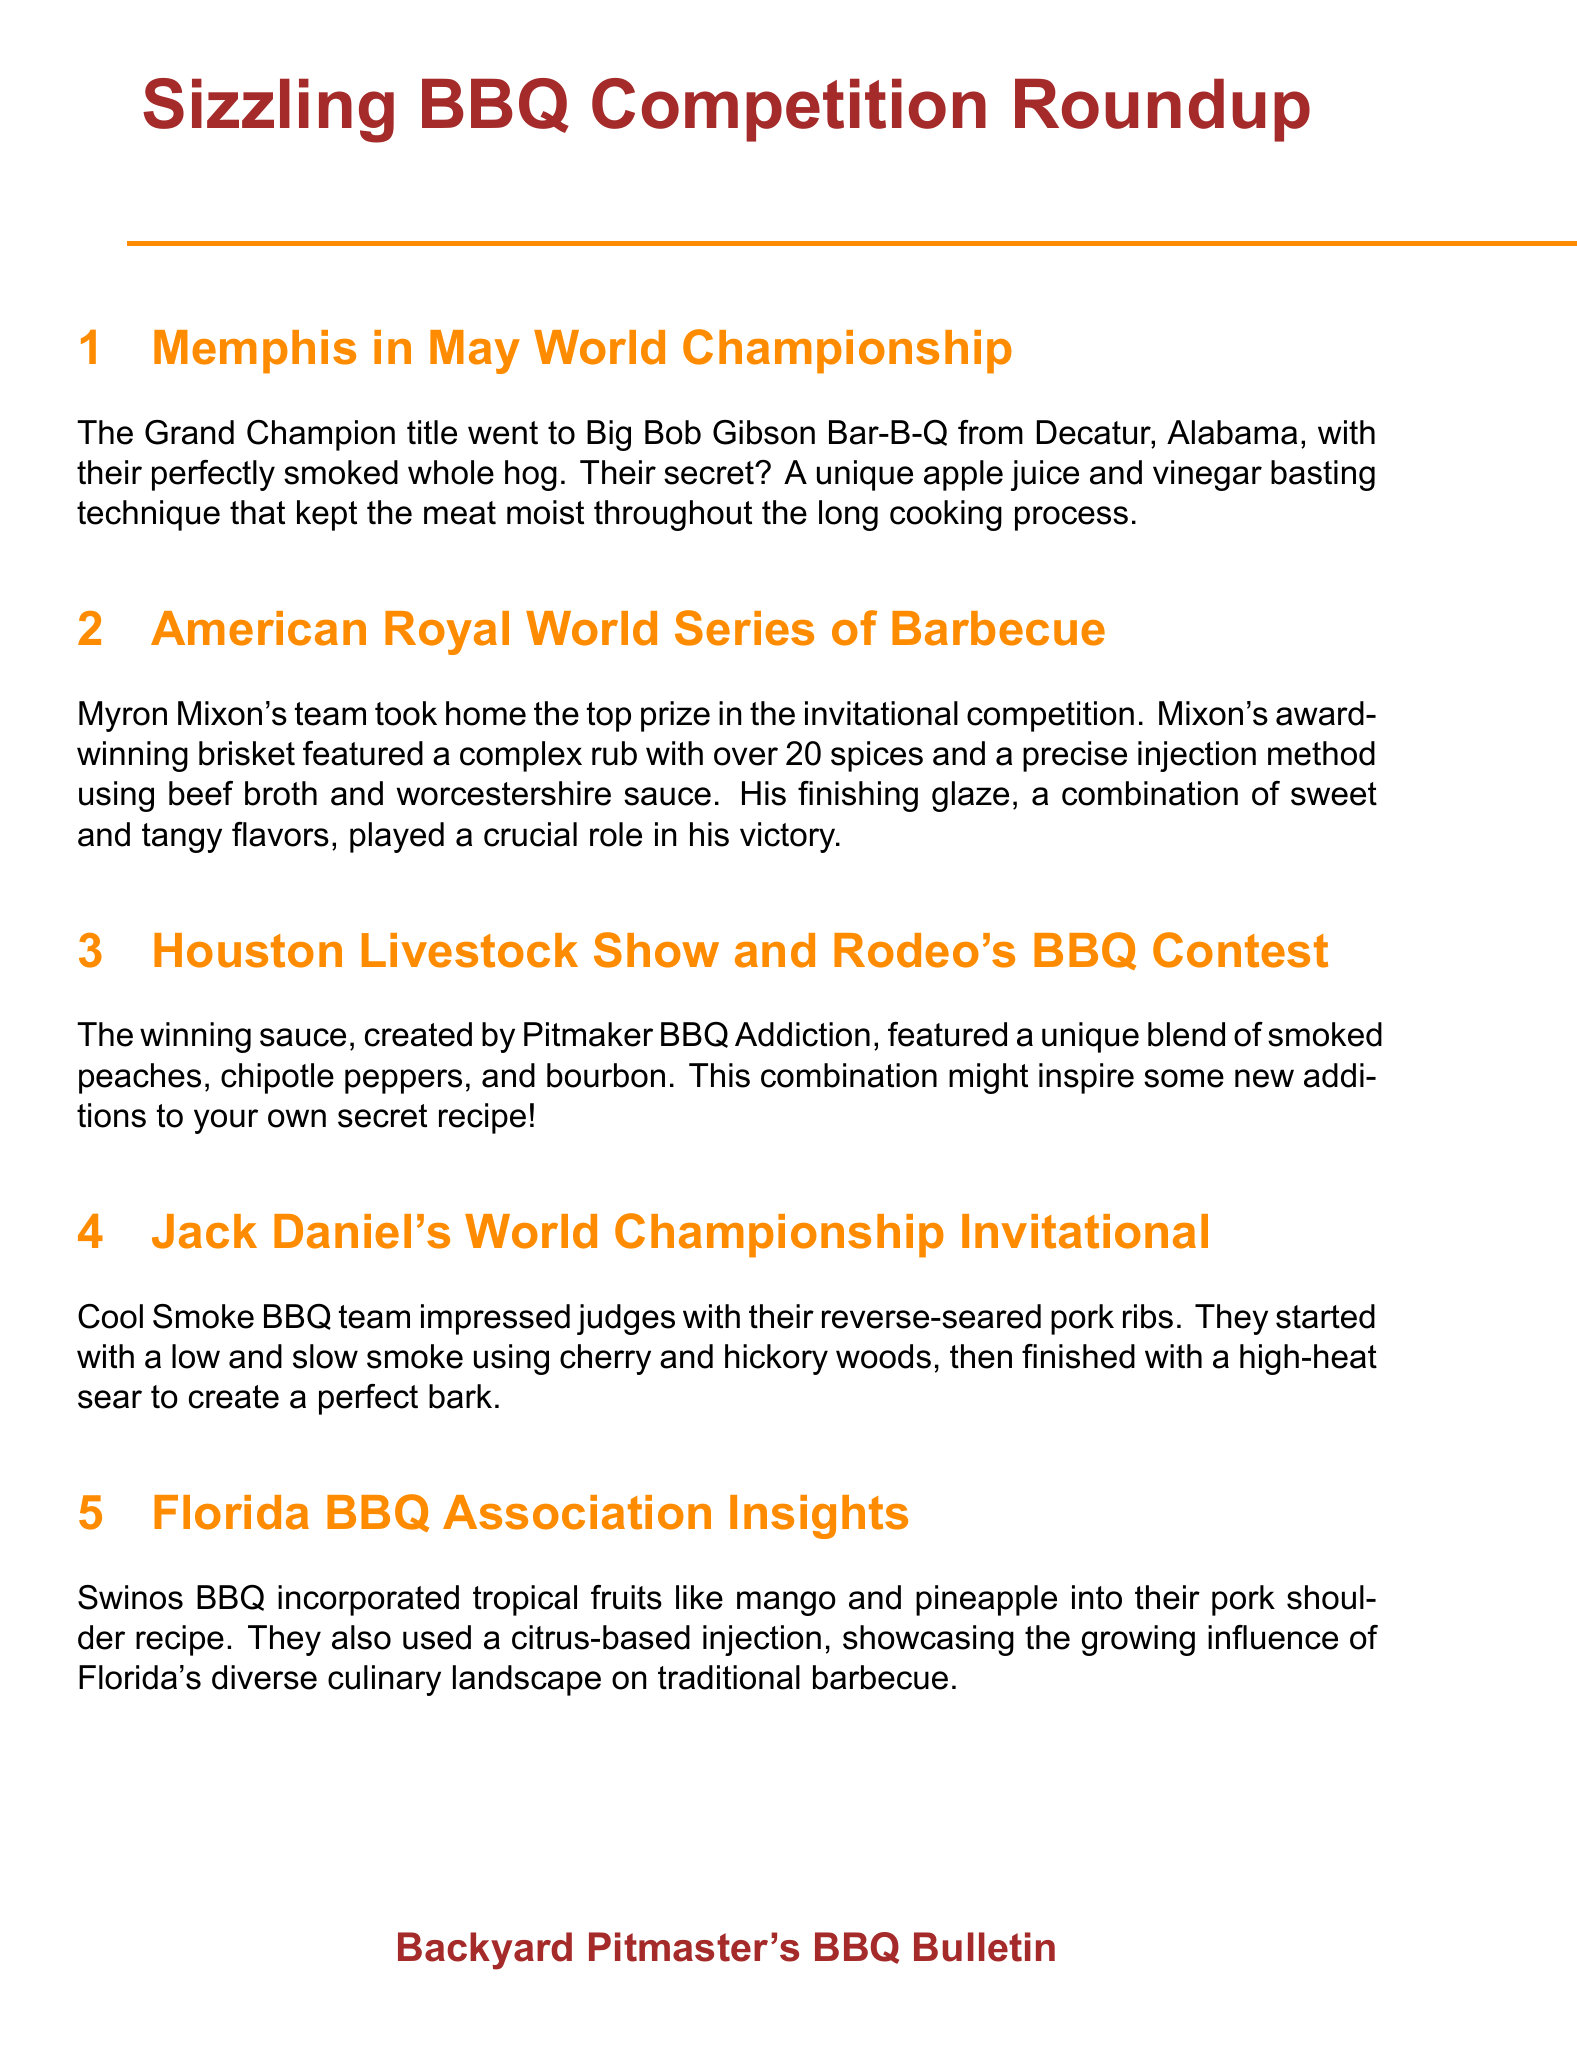What team won the Grand Champion title at Memphis in May? The Grand Champion title was awarded to Big Bob Gibson Bar-B-Q from Decatur, Alabama.
Answer: Big Bob Gibson Bar-B-Q What technique did Big Bob Gibson Bar-B-Q use to keep their meat moist? They used a unique apple juice and vinegar basting technique.
Answer: apple juice and vinegar basting How many spices were in Myron Mixon's award-winning brisket rub? Myron Mixon’s complex rub featured over 20 spices.
Answer: over 20 spices What flavors were combined in Myron Mixon's finishing glaze? Mixon's finishing glaze featured a combination of sweet and tangy flavors.
Answer: sweet and tangy What unique ingredients were used in the winning sauce at the Houston Rodeo BBQ contest? The winning sauce featured smoked peaches, chipotle peppers, and bourbon.
Answer: smoked peaches, chipotle peppers, and bourbon What smoking method was used by Cool Smoke BBQ for their pork ribs? They used a reverse-seared technique, starting with low and slow smoke.
Answer: reverse-seared What tropical fruits did Swinos BBQ incorporate into their pork shoulder recipe? They incorporated mango and pineapple into their recipe.
Answer: mango and pineapple What cooking method was highlighted at the EGGtoberfest for beef short ribs? The notable method was 'low and slow' followed by a 'hot and fast' approach.
Answer: 'low and slow' followed by 'hot and fast' What was the central theme of the newsletter? The newsletter focused on BBQ competition results and techniques.
Answer: BBQ competition results and techniques 